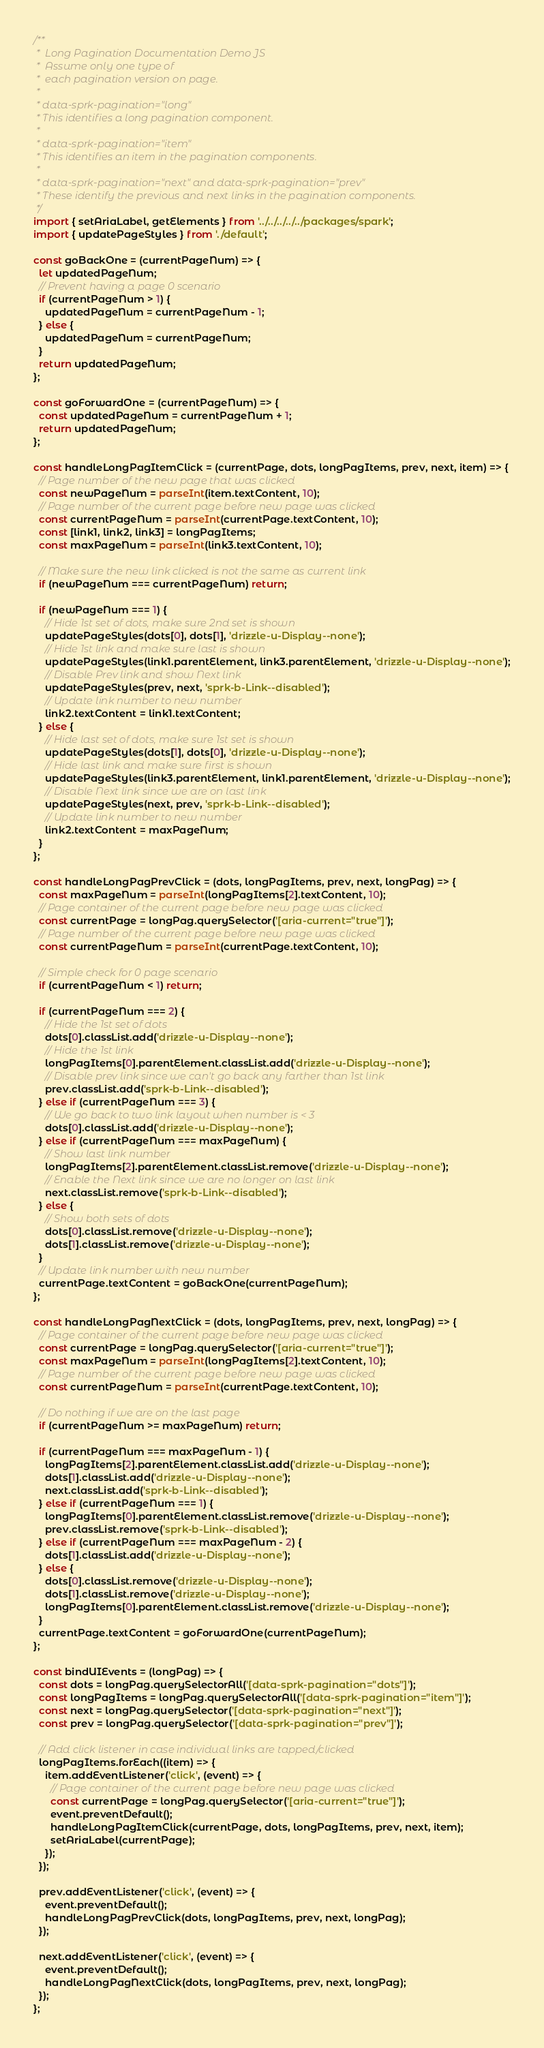<code> <loc_0><loc_0><loc_500><loc_500><_JavaScript_>/**
 *  Long Pagination Documentation Demo JS
 *  Assume only one type of
 *  each pagination version on page.
 *
 * data-sprk-pagination="long"
 * This identifies a long pagination component.
 *
 * data-sprk-pagination="item"
 * This identifies an item in the pagination components.
 *
 * data-sprk-pagination="next" and data-sprk-pagination="prev"
 * These identify the previous and next links in the pagination components.
 */
import { setAriaLabel, getElements } from '../../../../../packages/spark';
import { updatePageStyles } from './default';

const goBackOne = (currentPageNum) => {
  let updatedPageNum;
  // Prevent having a page 0 scenario
  if (currentPageNum > 1) {
    updatedPageNum = currentPageNum - 1;
  } else {
    updatedPageNum = currentPageNum;
  }
  return updatedPageNum;
};

const goForwardOne = (currentPageNum) => {
  const updatedPageNum = currentPageNum + 1;
  return updatedPageNum;
};

const handleLongPagItemClick = (currentPage, dots, longPagItems, prev, next, item) => {
  // Page number of the new page that was clicked
  const newPageNum = parseInt(item.textContent, 10);
  // Page number of the current page before new page was clicked
  const currentPageNum = parseInt(currentPage.textContent, 10);
  const [link1, link2, link3] = longPagItems;
  const maxPageNum = parseInt(link3.textContent, 10);

  // Make sure the new link clicked is not the same as current link
  if (newPageNum === currentPageNum) return;

  if (newPageNum === 1) {
    // Hide 1st set of dots, make sure 2nd set is shown
    updatePageStyles(dots[0], dots[1], 'drizzle-u-Display--none');
    // Hide 1st link and make sure last is shown
    updatePageStyles(link1.parentElement, link3.parentElement, 'drizzle-u-Display--none');
    // Disable Prev link and show Next link
    updatePageStyles(prev, next, 'sprk-b-Link--disabled');
    // Update link number to new number
    link2.textContent = link1.textContent;
  } else {
    // Hide last set of dots, make sure 1st set is shown
    updatePageStyles(dots[1], dots[0], 'drizzle-u-Display--none');
    // Hide last link and make sure first is shown
    updatePageStyles(link3.parentElement, link1.parentElement, 'drizzle-u-Display--none');
    // Disable Next link since we are on last link
    updatePageStyles(next, prev, 'sprk-b-Link--disabled');
    // Update link number to new number
    link2.textContent = maxPageNum;
  }
};

const handleLongPagPrevClick = (dots, longPagItems, prev, next, longPag) => {
  const maxPageNum = parseInt(longPagItems[2].textContent, 10);
  // Page container of the current page before new page was clicked
  const currentPage = longPag.querySelector('[aria-current="true"]');
  // Page number of the current page before new page was clicked
  const currentPageNum = parseInt(currentPage.textContent, 10);

  // Simple check for 0 page scenario
  if (currentPageNum < 1) return;

  if (currentPageNum === 2) {
    // Hide the 1st set of dots
    dots[0].classList.add('drizzle-u-Display--none');
    // Hide the 1st link
    longPagItems[0].parentElement.classList.add('drizzle-u-Display--none');
    // Disable prev link since we can't go back any farther than 1st link
    prev.classList.add('sprk-b-Link--disabled');
  } else if (currentPageNum === 3) {
    // We go back to two link layout when number is < 3
    dots[0].classList.add('drizzle-u-Display--none');
  } else if (currentPageNum === maxPageNum) {
    // Show last link number
    longPagItems[2].parentElement.classList.remove('drizzle-u-Display--none');
    // Enable the Next link since we are no longer on last link
    next.classList.remove('sprk-b-Link--disabled');
  } else {
    // Show both sets of dots
    dots[0].classList.remove('drizzle-u-Display--none');
    dots[1].classList.remove('drizzle-u-Display--none');
  }
  // Update link number with new number
  currentPage.textContent = goBackOne(currentPageNum);
};

const handleLongPagNextClick = (dots, longPagItems, prev, next, longPag) => {
  // Page container of the current page before new page was clicked
  const currentPage = longPag.querySelector('[aria-current="true"]');
  const maxPageNum = parseInt(longPagItems[2].textContent, 10);
  // Page number of the current page before new page was clicked
  const currentPageNum = parseInt(currentPage.textContent, 10);

  // Do nothing if we are on the last page
  if (currentPageNum >= maxPageNum) return;

  if (currentPageNum === maxPageNum - 1) {
    longPagItems[2].parentElement.classList.add('drizzle-u-Display--none');
    dots[1].classList.add('drizzle-u-Display--none');
    next.classList.add('sprk-b-Link--disabled');
  } else if (currentPageNum === 1) {
    longPagItems[0].parentElement.classList.remove('drizzle-u-Display--none');
    prev.classList.remove('sprk-b-Link--disabled');
  } else if (currentPageNum === maxPageNum - 2) {
    dots[1].classList.add('drizzle-u-Display--none');
  } else {
    dots[0].classList.remove('drizzle-u-Display--none');
    dots[1].classList.remove('drizzle-u-Display--none');
    longPagItems[0].parentElement.classList.remove('drizzle-u-Display--none');
  }
  currentPage.textContent = goForwardOne(currentPageNum);
};

const bindUIEvents = (longPag) => {
  const dots = longPag.querySelectorAll('[data-sprk-pagination="dots"]');
  const longPagItems = longPag.querySelectorAll('[data-sprk-pagination="item"]');
  const next = longPag.querySelector('[data-sprk-pagination="next"]');
  const prev = longPag.querySelector('[data-sprk-pagination="prev"]');

  // Add click listener in case individual links are tapped/clicked
  longPagItems.forEach((item) => {
    item.addEventListener('click', (event) => {
      // Page container of the current page before new page was clicked
      const currentPage = longPag.querySelector('[aria-current="true"]');
      event.preventDefault();
      handleLongPagItemClick(currentPage, dots, longPagItems, prev, next, item);
      setAriaLabel(currentPage);
    });
  });

  prev.addEventListener('click', (event) => {
    event.preventDefault();
    handleLongPagPrevClick(dots, longPagItems, prev, next, longPag);
  });

  next.addEventListener('click', (event) => {
    event.preventDefault();
    handleLongPagNextClick(dots, longPagItems, prev, next, longPag);
  });
};
</code> 